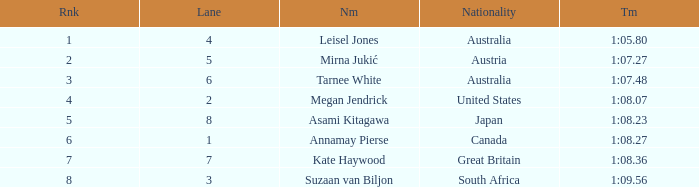What is the Nationality of the Swimmer in Lane 4 or larger with a Rank of 5 or more? Great Britain. 